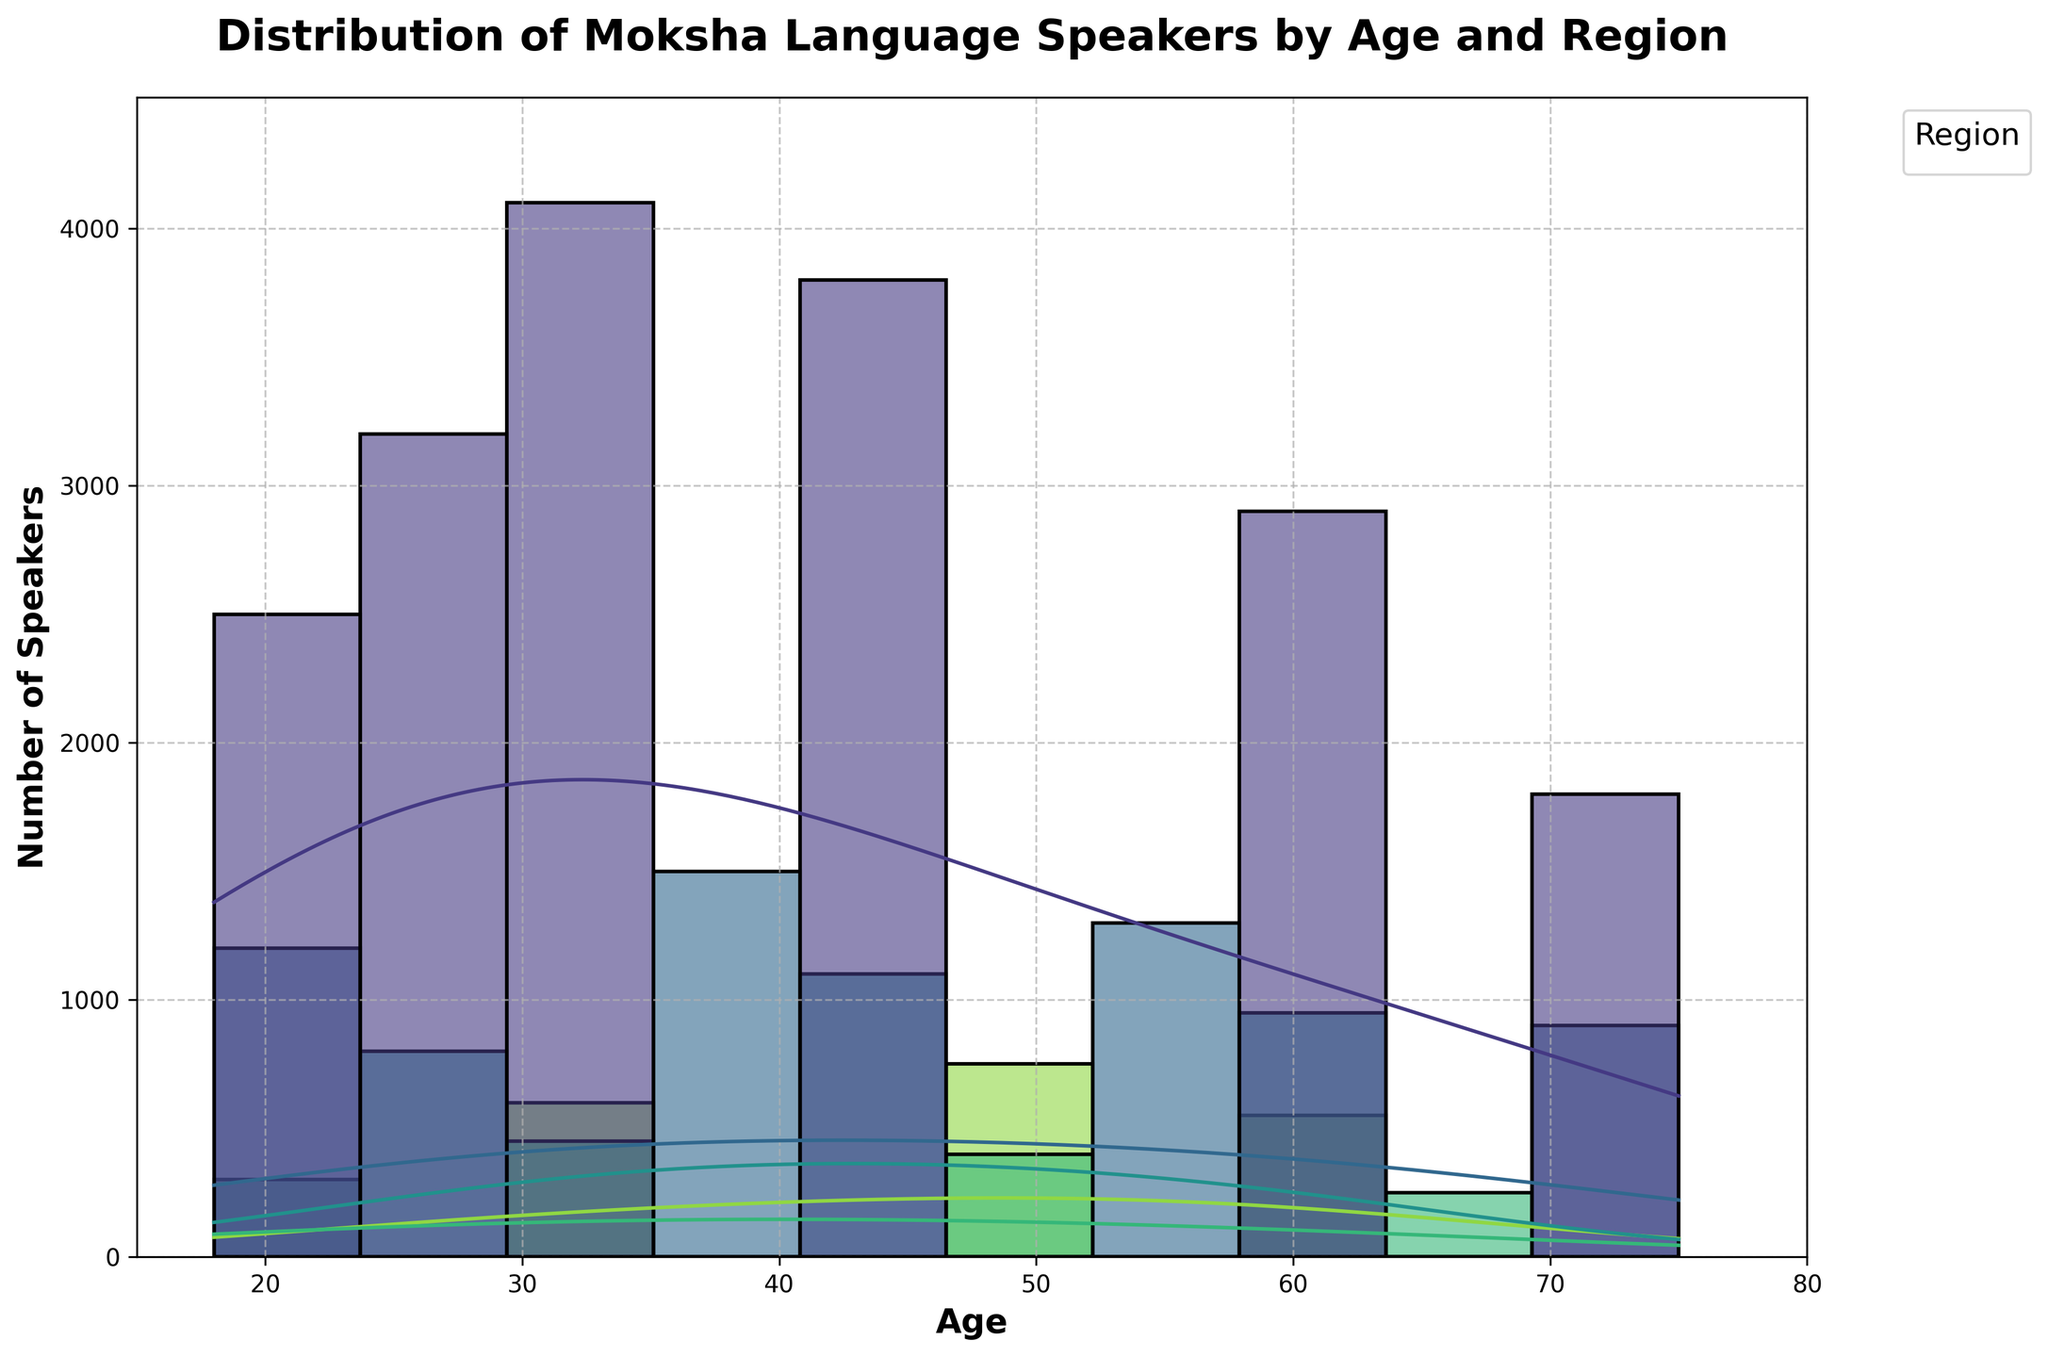What is the title of the plot? The title of the plot is usually located at the top center. In this case, the title reads "Distribution of Moksha Language Speakers by Age and Region".
Answer: Distribution of Moksha Language Speakers by Age and Region Which region has the highest number of speakers in the 25-40 age group? To determine this, look at the histogram bars for age ranging from 25 to 40 and identify which region's bars are the tallest. Here, Mordovia’s bars are the tallest, indicating the highest number of speakers.
Answer: Mordovia What is the trend of Moksha speakers in Mordovia as age increases? Look at the height and density of the bars and KDE curve specific to Mordovia. Initially, the number of speakers increases, reaches a peak around age 32, and then gradually decreases.
Answer: Increase then decrease How does the number of speakers in the 60+ age group differ between Mordovia and Penza Oblast? Compare the height of the histogram bars and the KDE curves for the age group 60+ in Mordovia and Penza Oblast. Mordovia has higher bars compared to Penza Oblast, indicating more speakers.
Answer: Mordovia has more speakers What is the approximate number of Moksha speakers in the 18-30 age group in Moscow? Look at the total height of the histogram bars between age 18 and 30 for Moscow. Adding them, there are about 300 (age 20) + 450 (age 35, roughly half for age 27) = approximately 450.
Answer: Approximately 450 How is the age distribution of Moksha speakers in Samara Oblast different from that in Saratov Oblast? Observe the distribution of histogram bars and KDE curves for both regions. Samara Oblast has a few speakers concentrated mostly around ages 28, 42, and 58, while Saratov Oblast shows more speakers distributed more evenly across the ages of 30, 48, and 62.
Answer: Concentrated vs. Evenly distributed Which age group in Penza Oblast has a notable drop in the number of Moksha speakers? Look for significant differences in bar heights. The age group around 70 shows a notable drop in Penza Oblast.
Answer: 70 What can you infer about the trend of younger (below 30) Moksha speakers in Moscow? Examine the KDE curve and histogram bars for ages below 30 in Moscow. There are fewer speakers in this age range as indicated by shorter bars and lower density.
Answer: Few younger speakers Which region has the smallest number of Moksha speakers overall? Compare the overall height and area under the KDE curves for each region. Moscow has the smallest number of speakers overall.
Answer: Moscow Which regions show a peak around the age of 45 in the distribution? Look at where the histogram bars and KDE curves peak around the age 45. Mordovia shows a notable peak around age 45.
Answer: Mordovia 